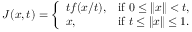Convert formula to latex. <formula><loc_0><loc_0><loc_500><loc_500>J ( x , t ) = { \left \{ \begin{array} { l l } { t f ( x / t ) , } & { { i f } 0 \leq \| x \| < t , } \\ { x , } & { { i f } t \leq \| x \| \leq 1 . } \end{array} }</formula> 